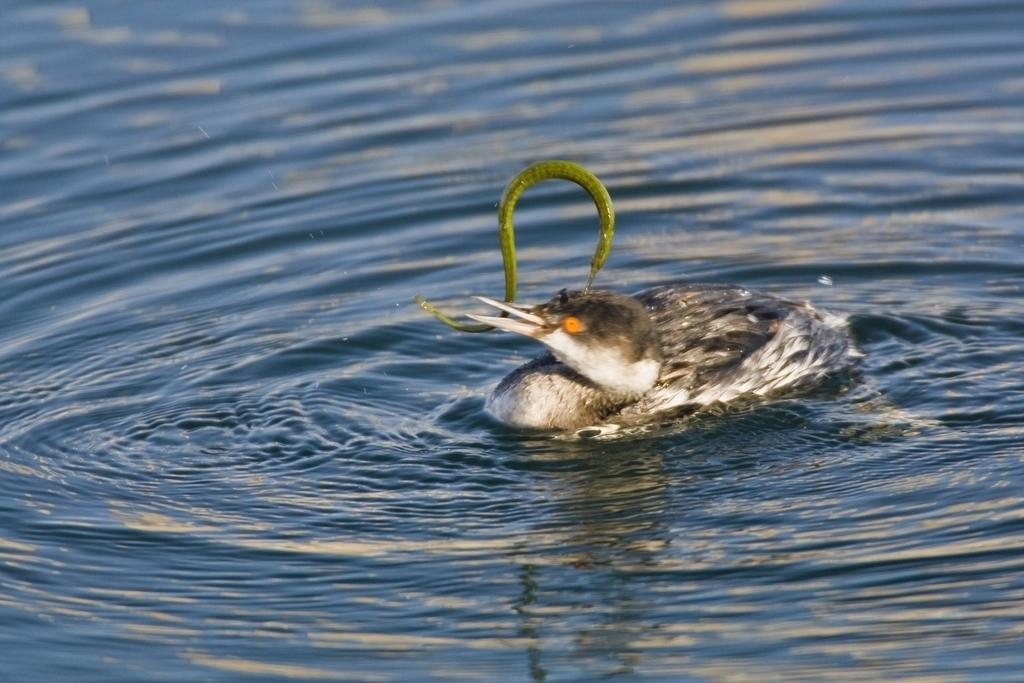What type of bird is in the image? There is a hooded merganser in the image. Where is the hooded merganser located in the image? The hooded merganser is in the center of the image. What is the hooded merganser doing in the image? The hooded merganser is on the water. What can be seen in the background of the image? There is water visible in the image. What type of battle is taking place on the table in the image? There is no table or battle present in the image; it features a hooded merganser on the water. 